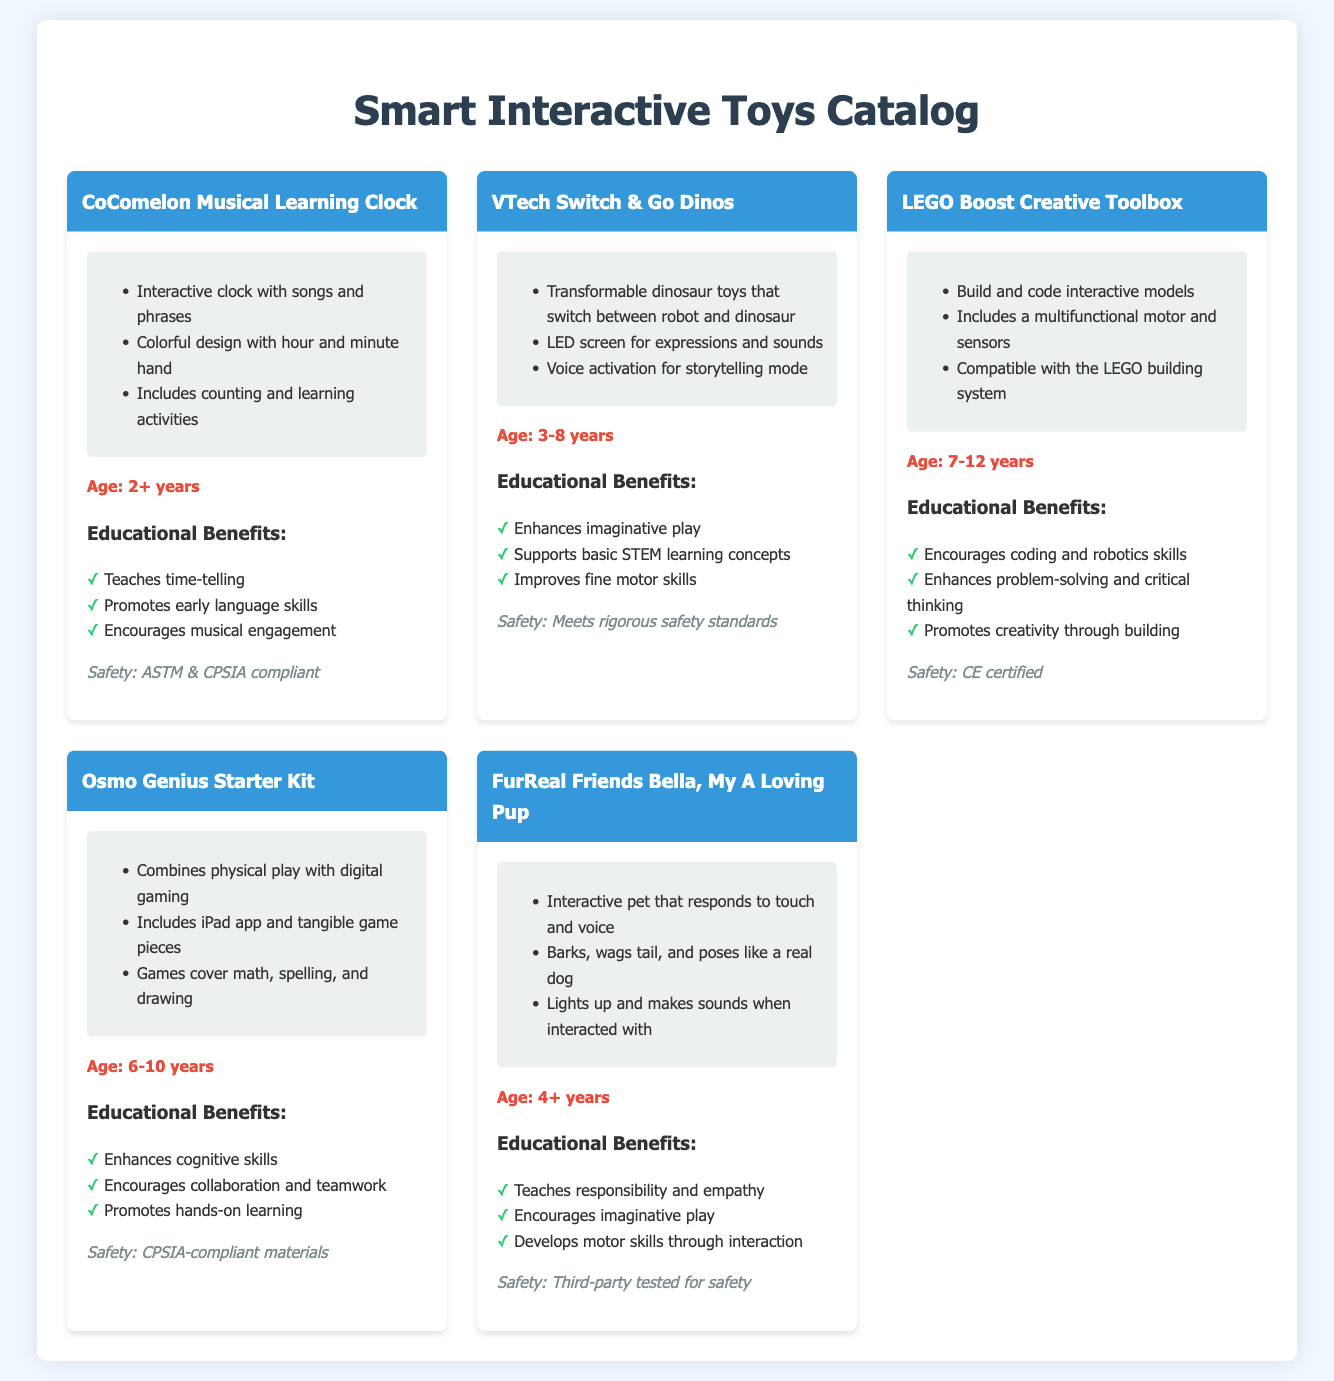What is the age recommendation for the CoComelon Musical Learning Clock? The age recommendation for the CoComelon Musical Learning Clock is listed as 2+ years in the document.
Answer: 2+ years What educational benefit does the VTech Switch & Go Dinos provide? The VTech Switch & Go Dinos enhances imaginative play, as stated in the educational benefits section of the document.
Answer: Enhances imaginative play Which toy includes a multifunctional motor and sensors? The LEGO Boost Creative Toolbox includes a multifunctional motor and sensors, as mentioned in the features of the toy.
Answer: LEGO Boost Creative Toolbox How many years is the age range for the Osmo Genius Starter Kit? The age range for the Osmo Genius Starter Kit is specified as 4 years (6-10 years).
Answer: 4 years What safety compliance does the FurReal Friends Bella, My A Loving Pup meet? The FurReal Friends Bella, My A Loving Pup is tested for safety by third-party standards, according to the safety section.
Answer: Third-party tested for safety What interactive feature does the CoComelon Musical Learning Clock have? The CoComelon Musical Learning Clock features an interactive clock with songs and phrases, as indicated in the features list.
Answer: Interactive clock with songs and phrases What type of educational skills does the LEGO Boost Creative Toolbox promote? The LEGO Boost Creative Toolbox promotes coding and robotics skills, which is mentioned in the educational benefits section.
Answer: Coding and robotics skills Which toy combines physical play with digital gaming? The Osmo Genius Starter Kit combines physical play with digital gaming as detailed in the features of the toy.
Answer: Osmo Genius Starter Kit 